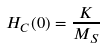<formula> <loc_0><loc_0><loc_500><loc_500>H _ { C } ( 0 ) = \frac { K } { M _ { S } }</formula> 